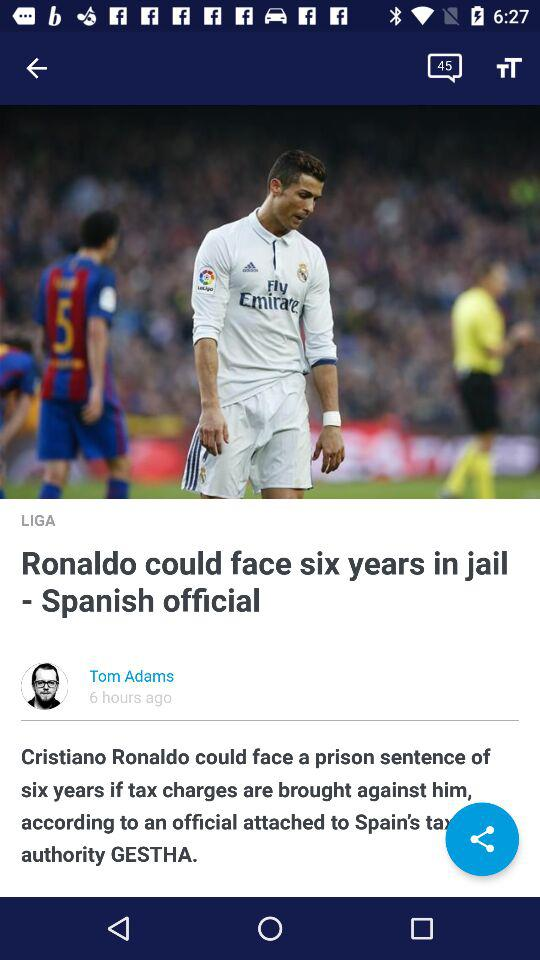Who is the author of the article? The author of the article is Tom Adams. 